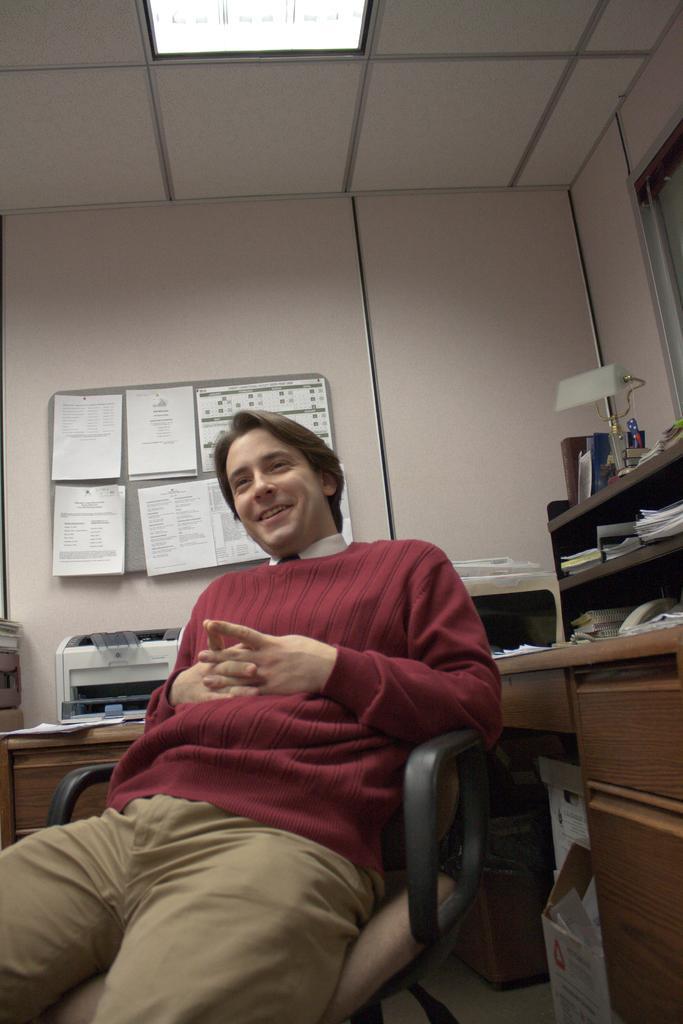Could you give a brief overview of what you see in this image? In this image i can see a man sitting on a chair at the back ground i can see a cupboard few books in it, a board and a wall. 